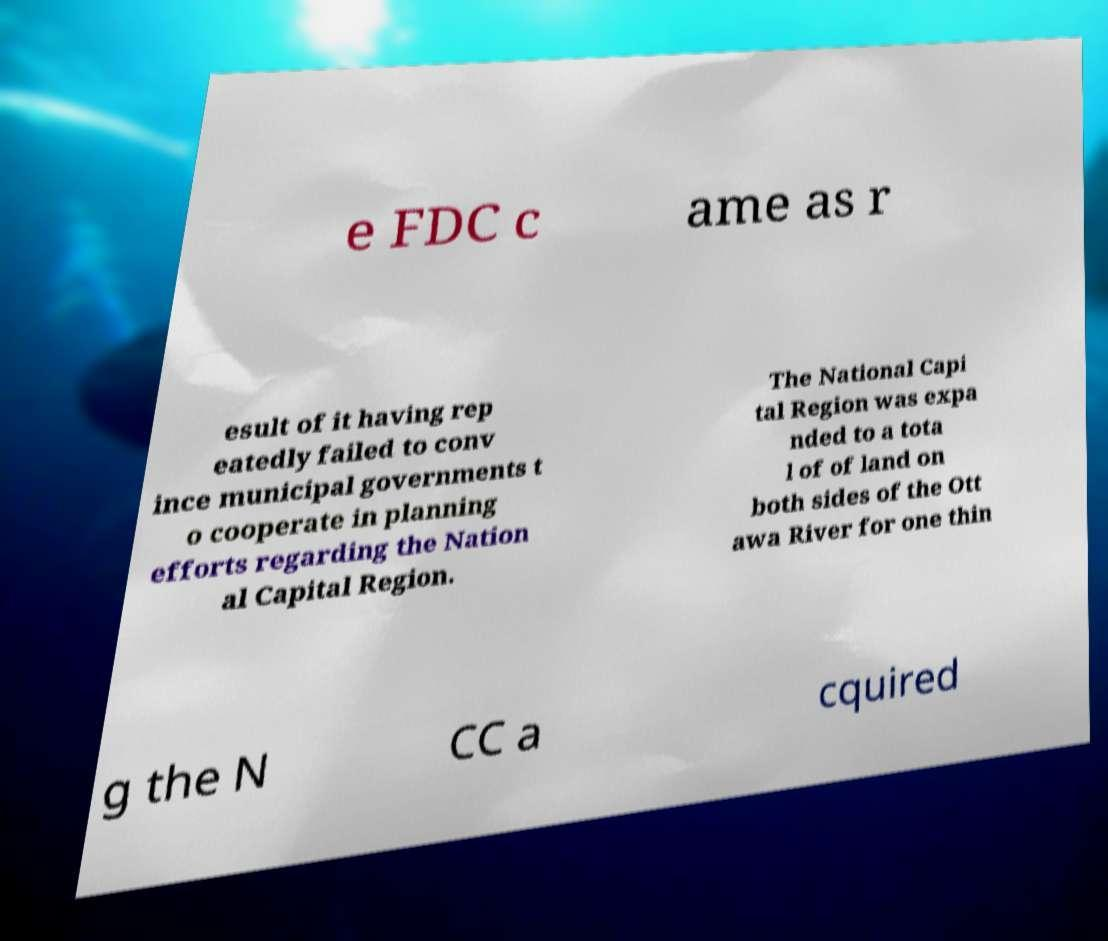There's text embedded in this image that I need extracted. Can you transcribe it verbatim? e FDC c ame as r esult of it having rep eatedly failed to conv ince municipal governments t o cooperate in planning efforts regarding the Nation al Capital Region. The National Capi tal Region was expa nded to a tota l of of land on both sides of the Ott awa River for one thin g the N CC a cquired 